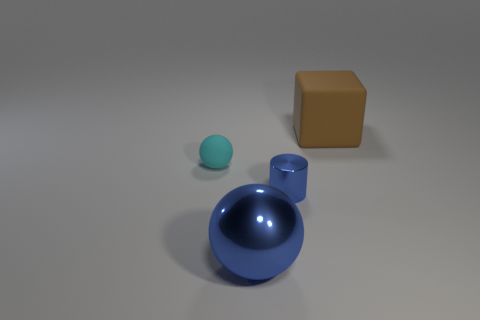Add 3 green shiny balls. How many objects exist? 7 Subtract all cubes. How many objects are left? 3 Subtract all cyan matte objects. Subtract all small blue metallic cylinders. How many objects are left? 2 Add 3 brown objects. How many brown objects are left? 4 Add 2 blue matte objects. How many blue matte objects exist? 2 Subtract 0 cyan cylinders. How many objects are left? 4 